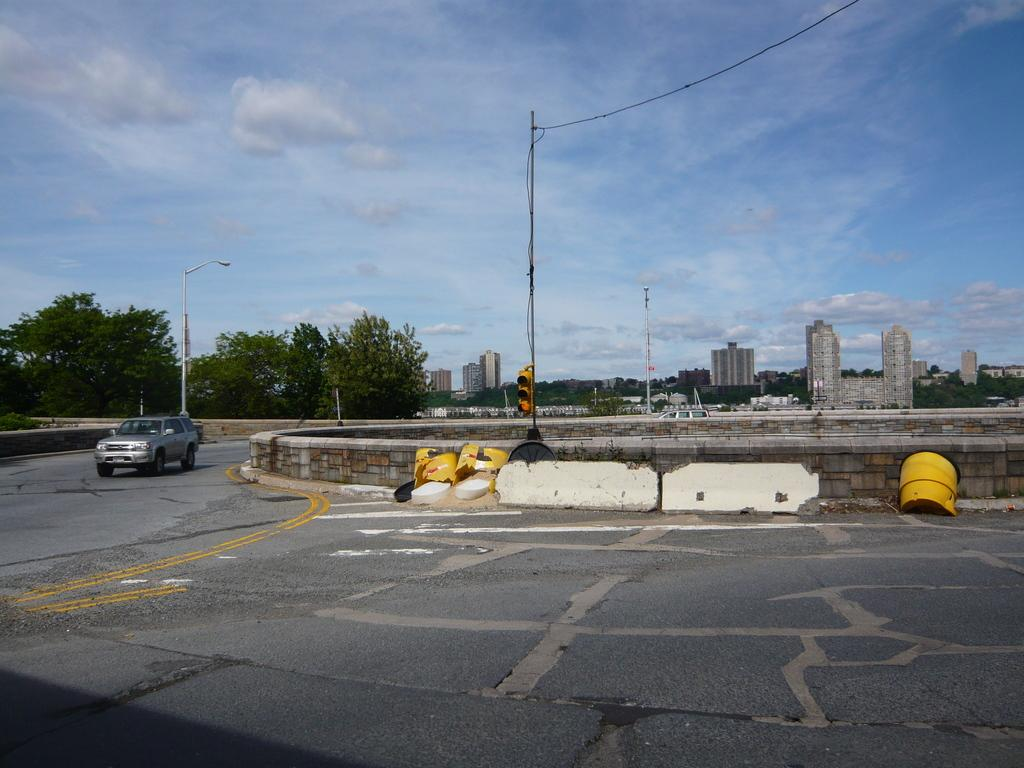What is on the road in the image? There is a vehicle on the road in the image. What type of natural elements can be seen in the image? There are trees visible in the image. What type of structure is present in the image? There is a light pole in the image. What type of man-made structures are visible in the image? There are buildings in the image. How would you describe the weather in the image? The sky is cloudy in the image. What other type of pole can be seen in the image? There is a signal pole in the image. What type of wool is being spun by the sheep in the image? There are no sheep or wool present in the image; it features a vehicle on the road, trees, a light pole, buildings, and a cloudy sky. 